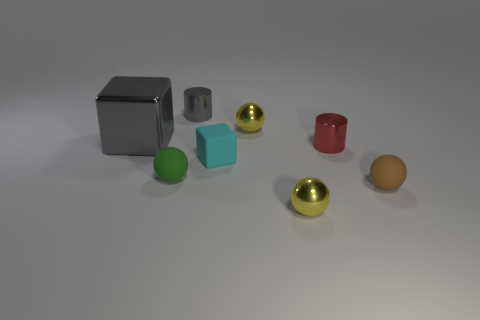Add 1 tiny brown matte blocks. How many objects exist? 9 Subtract all cylinders. How many objects are left? 6 Add 4 tiny green spheres. How many tiny green spheres exist? 5 Subtract 0 brown cylinders. How many objects are left? 8 Subtract all red shiny cylinders. Subtract all cyan cubes. How many objects are left? 6 Add 3 tiny gray objects. How many tiny gray objects are left? 4 